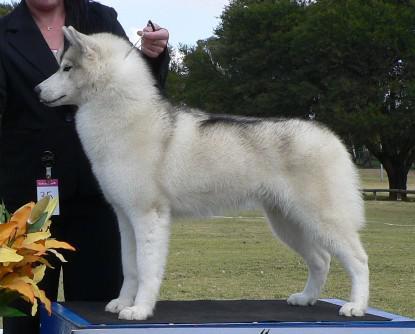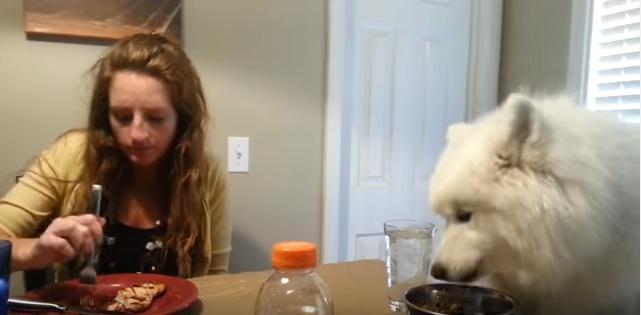The first image is the image on the left, the second image is the image on the right. Considering the images on both sides, is "Each image contains a single white dog, and at least one image features a dog standing on all fours with its body turned leftward." valid? Answer yes or no. Yes. The first image is the image on the left, the second image is the image on the right. For the images displayed, is the sentence "One of the images features a dog eating at a dinner table." factually correct? Answer yes or no. Yes. 